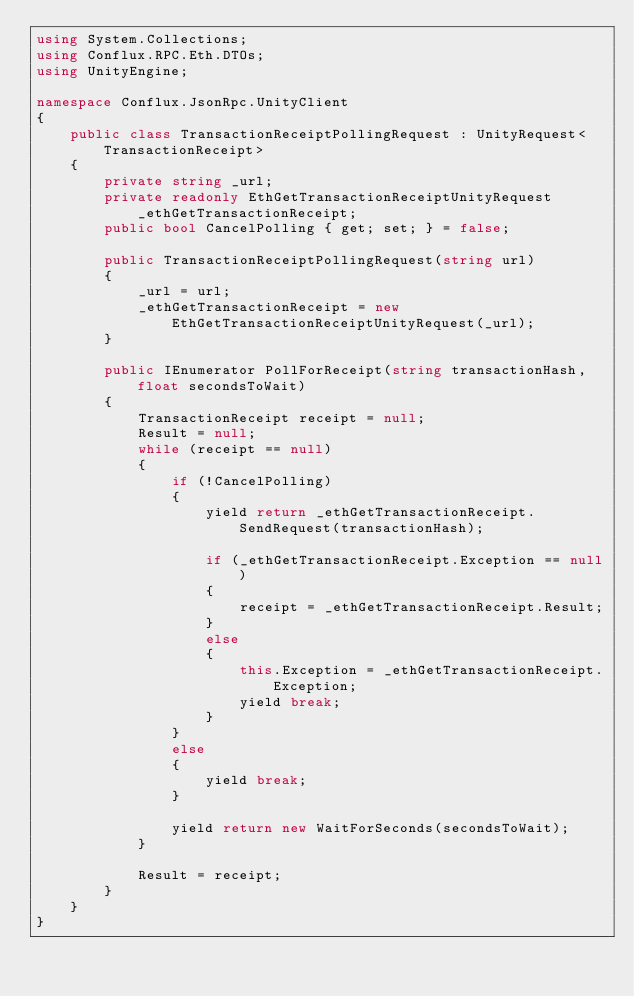<code> <loc_0><loc_0><loc_500><loc_500><_C#_>using System.Collections;
using Conflux.RPC.Eth.DTOs;
using UnityEngine;

namespace Conflux.JsonRpc.UnityClient
{
    public class TransactionReceiptPollingRequest : UnityRequest<TransactionReceipt>
    {
        private string _url;
        private readonly EthGetTransactionReceiptUnityRequest _ethGetTransactionReceipt;
        public bool CancelPolling { get; set; } = false;

        public TransactionReceiptPollingRequest(string url)
        {
            _url = url;
            _ethGetTransactionReceipt = new EthGetTransactionReceiptUnityRequest(_url);
        }

        public IEnumerator PollForReceipt(string transactionHash, float secondsToWait)
        {
            TransactionReceipt receipt = null;
            Result = null;
            while (receipt == null)
            {
                if (!CancelPolling)
                {
                    yield return _ethGetTransactionReceipt.SendRequest(transactionHash);

                    if (_ethGetTransactionReceipt.Exception == null)
                    {
                        receipt = _ethGetTransactionReceipt.Result;
                    }
                    else
                    {
                        this.Exception = _ethGetTransactionReceipt.Exception;
                        yield break;
                    }
                }
                else
                {
                    yield break;
                }

                yield return new WaitForSeconds(secondsToWait);
            }

            Result = receipt;
        }
    }
}</code> 